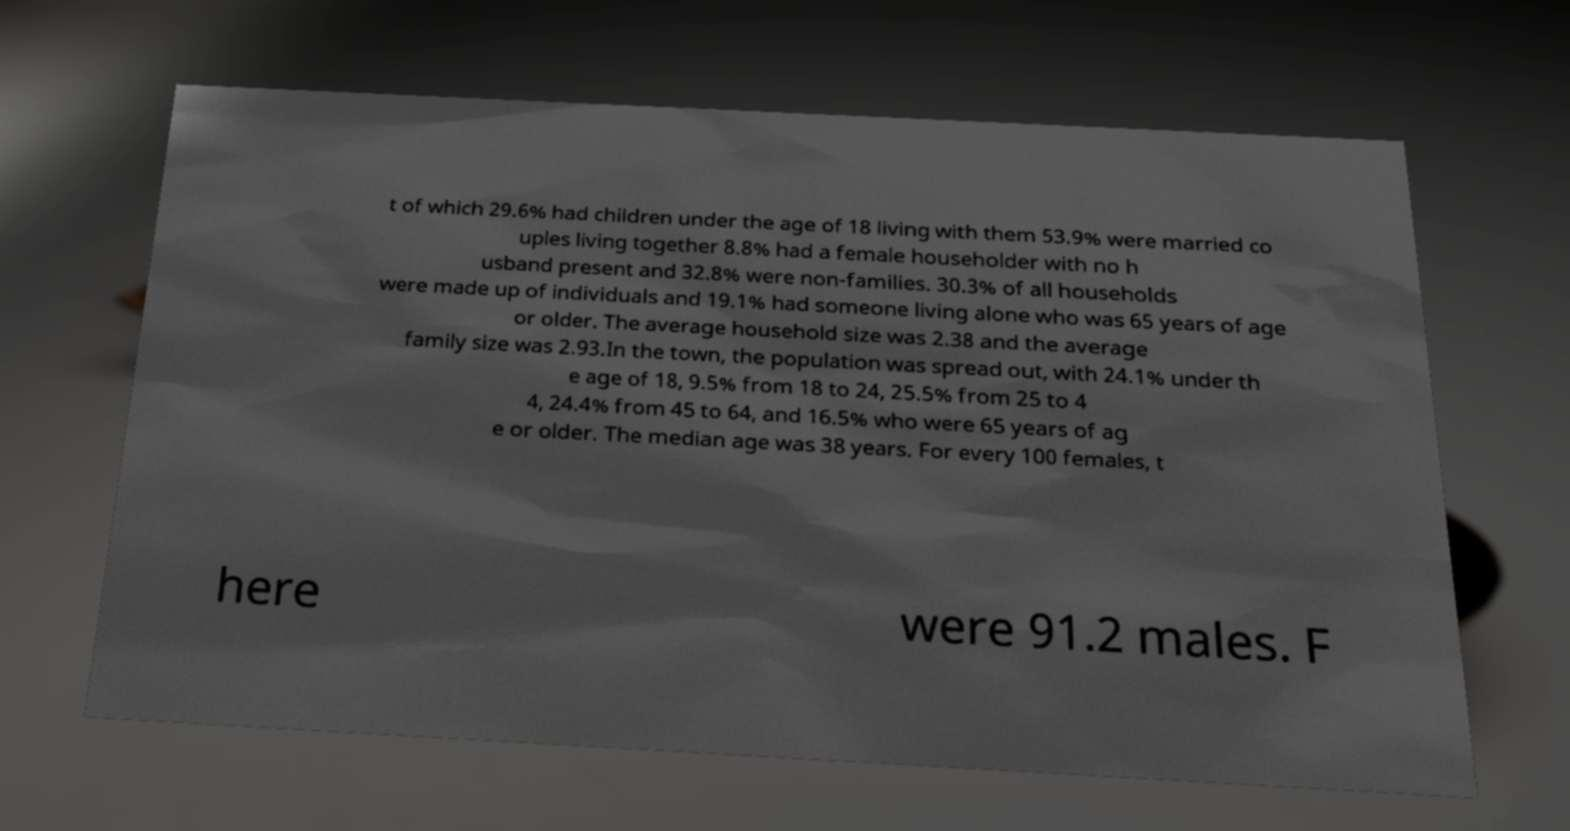Could you assist in decoding the text presented in this image and type it out clearly? t of which 29.6% had children under the age of 18 living with them 53.9% were married co uples living together 8.8% had a female householder with no h usband present and 32.8% were non-families. 30.3% of all households were made up of individuals and 19.1% had someone living alone who was 65 years of age or older. The average household size was 2.38 and the average family size was 2.93.In the town, the population was spread out, with 24.1% under th e age of 18, 9.5% from 18 to 24, 25.5% from 25 to 4 4, 24.4% from 45 to 64, and 16.5% who were 65 years of ag e or older. The median age was 38 years. For every 100 females, t here were 91.2 males. F 